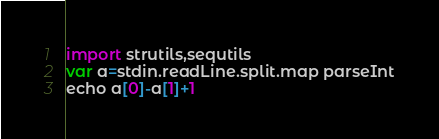<code> <loc_0><loc_0><loc_500><loc_500><_Nim_>import strutils,sequtils
var a=stdin.readLine.split.map parseInt
echo a[0]-a[1]+1</code> 